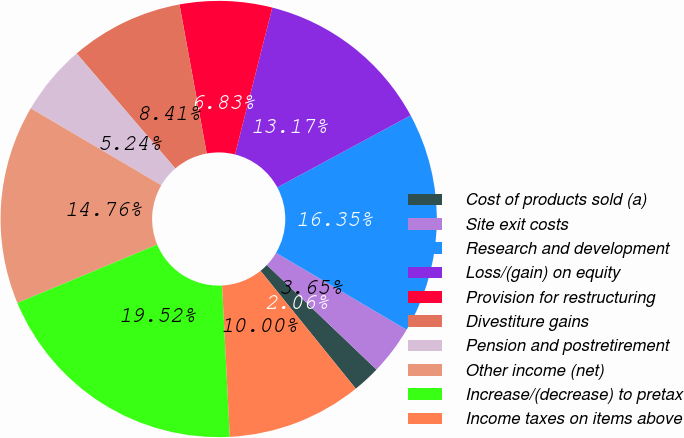Convert chart to OTSL. <chart><loc_0><loc_0><loc_500><loc_500><pie_chart><fcel>Cost of products sold (a)<fcel>Site exit costs<fcel>Research and development<fcel>Loss/(gain) on equity<fcel>Provision for restructuring<fcel>Divestiture gains<fcel>Pension and postretirement<fcel>Other income (net)<fcel>Increase/(decrease) to pretax<fcel>Income taxes on items above<nl><fcel>2.06%<fcel>3.65%<fcel>16.35%<fcel>13.17%<fcel>6.83%<fcel>8.41%<fcel>5.24%<fcel>14.76%<fcel>19.52%<fcel>10.0%<nl></chart> 